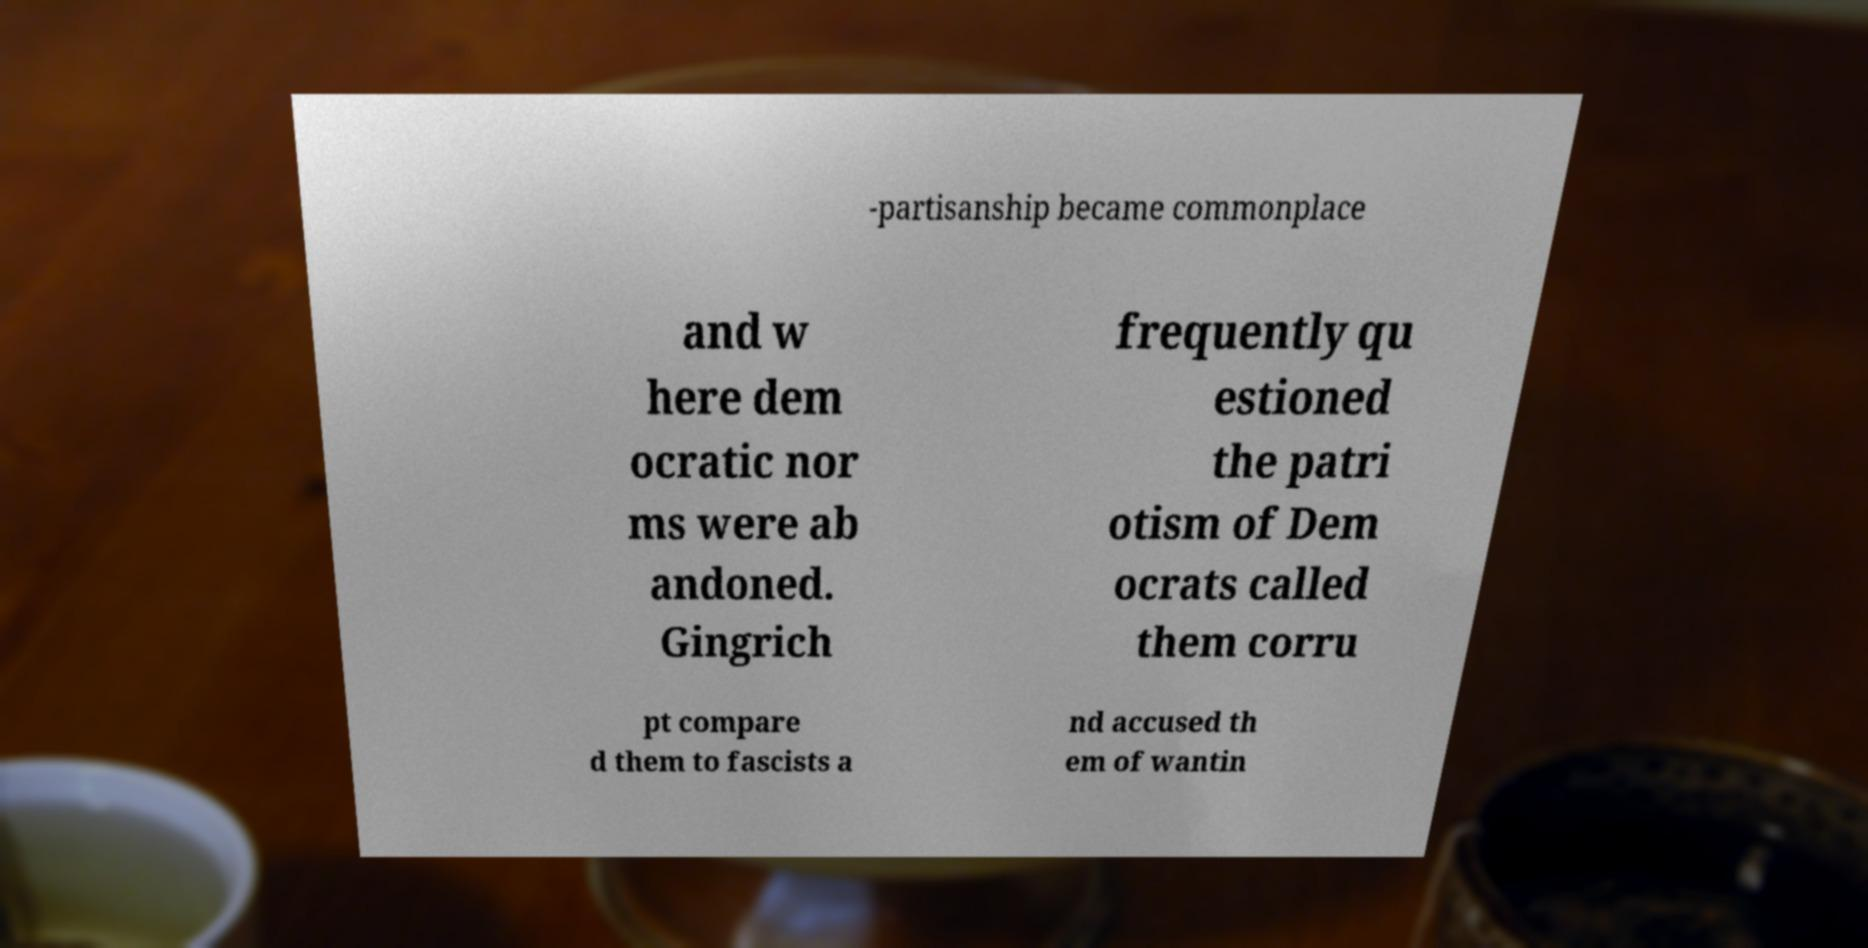Please identify and transcribe the text found in this image. -partisanship became commonplace and w here dem ocratic nor ms were ab andoned. Gingrich frequently qu estioned the patri otism of Dem ocrats called them corru pt compare d them to fascists a nd accused th em of wantin 